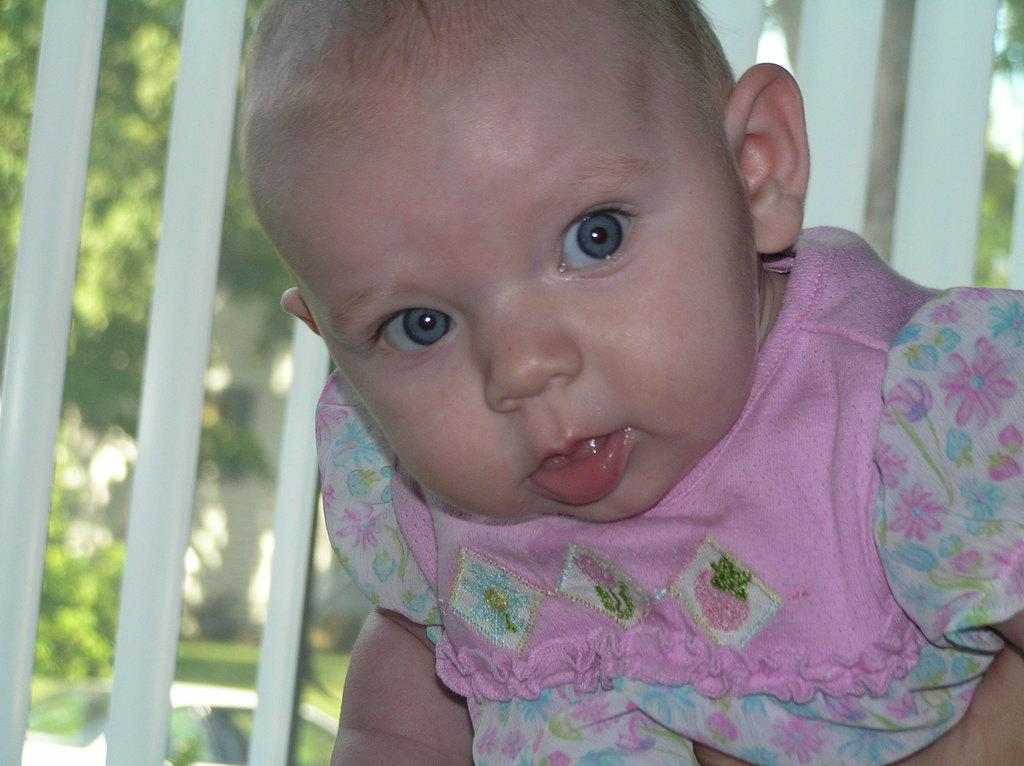What is the main subject of the image? There is a baby in the image. What can be seen behind the baby? There is a wooden fence behind the baby. What is located behind the wooden fence? There is a car behind the wooden fence. What type of vegetation is visible behind the car? There are trees behind the car. What architectural feature can be seen in the image? There is a wall visible in the image. What type of stamp can be seen on the baby's forehead in the image? There is no stamp visible on the baby's forehead in the image. Is there a carpenter working on the wall in the image? There is no carpenter or any indication of construction work in the image. 